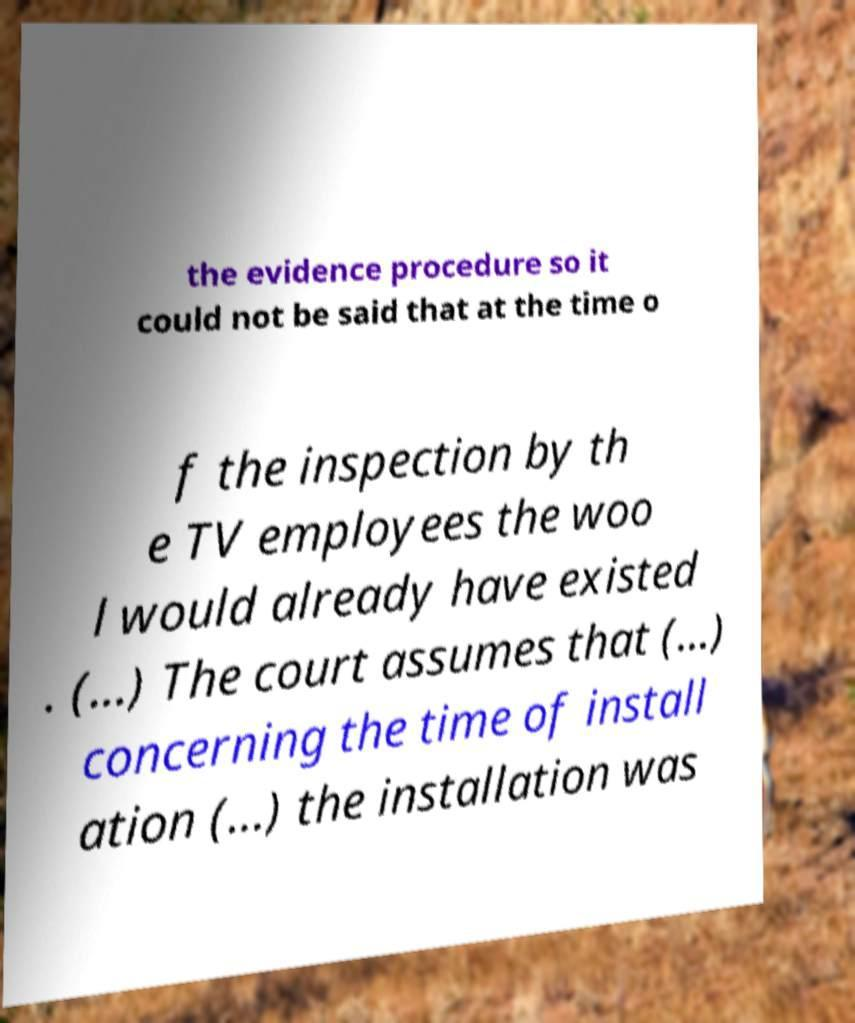Could you extract and type out the text from this image? the evidence procedure so it could not be said that at the time o f the inspection by th e TV employees the woo l would already have existed . (...) The court assumes that (...) concerning the time of install ation (...) the installation was 